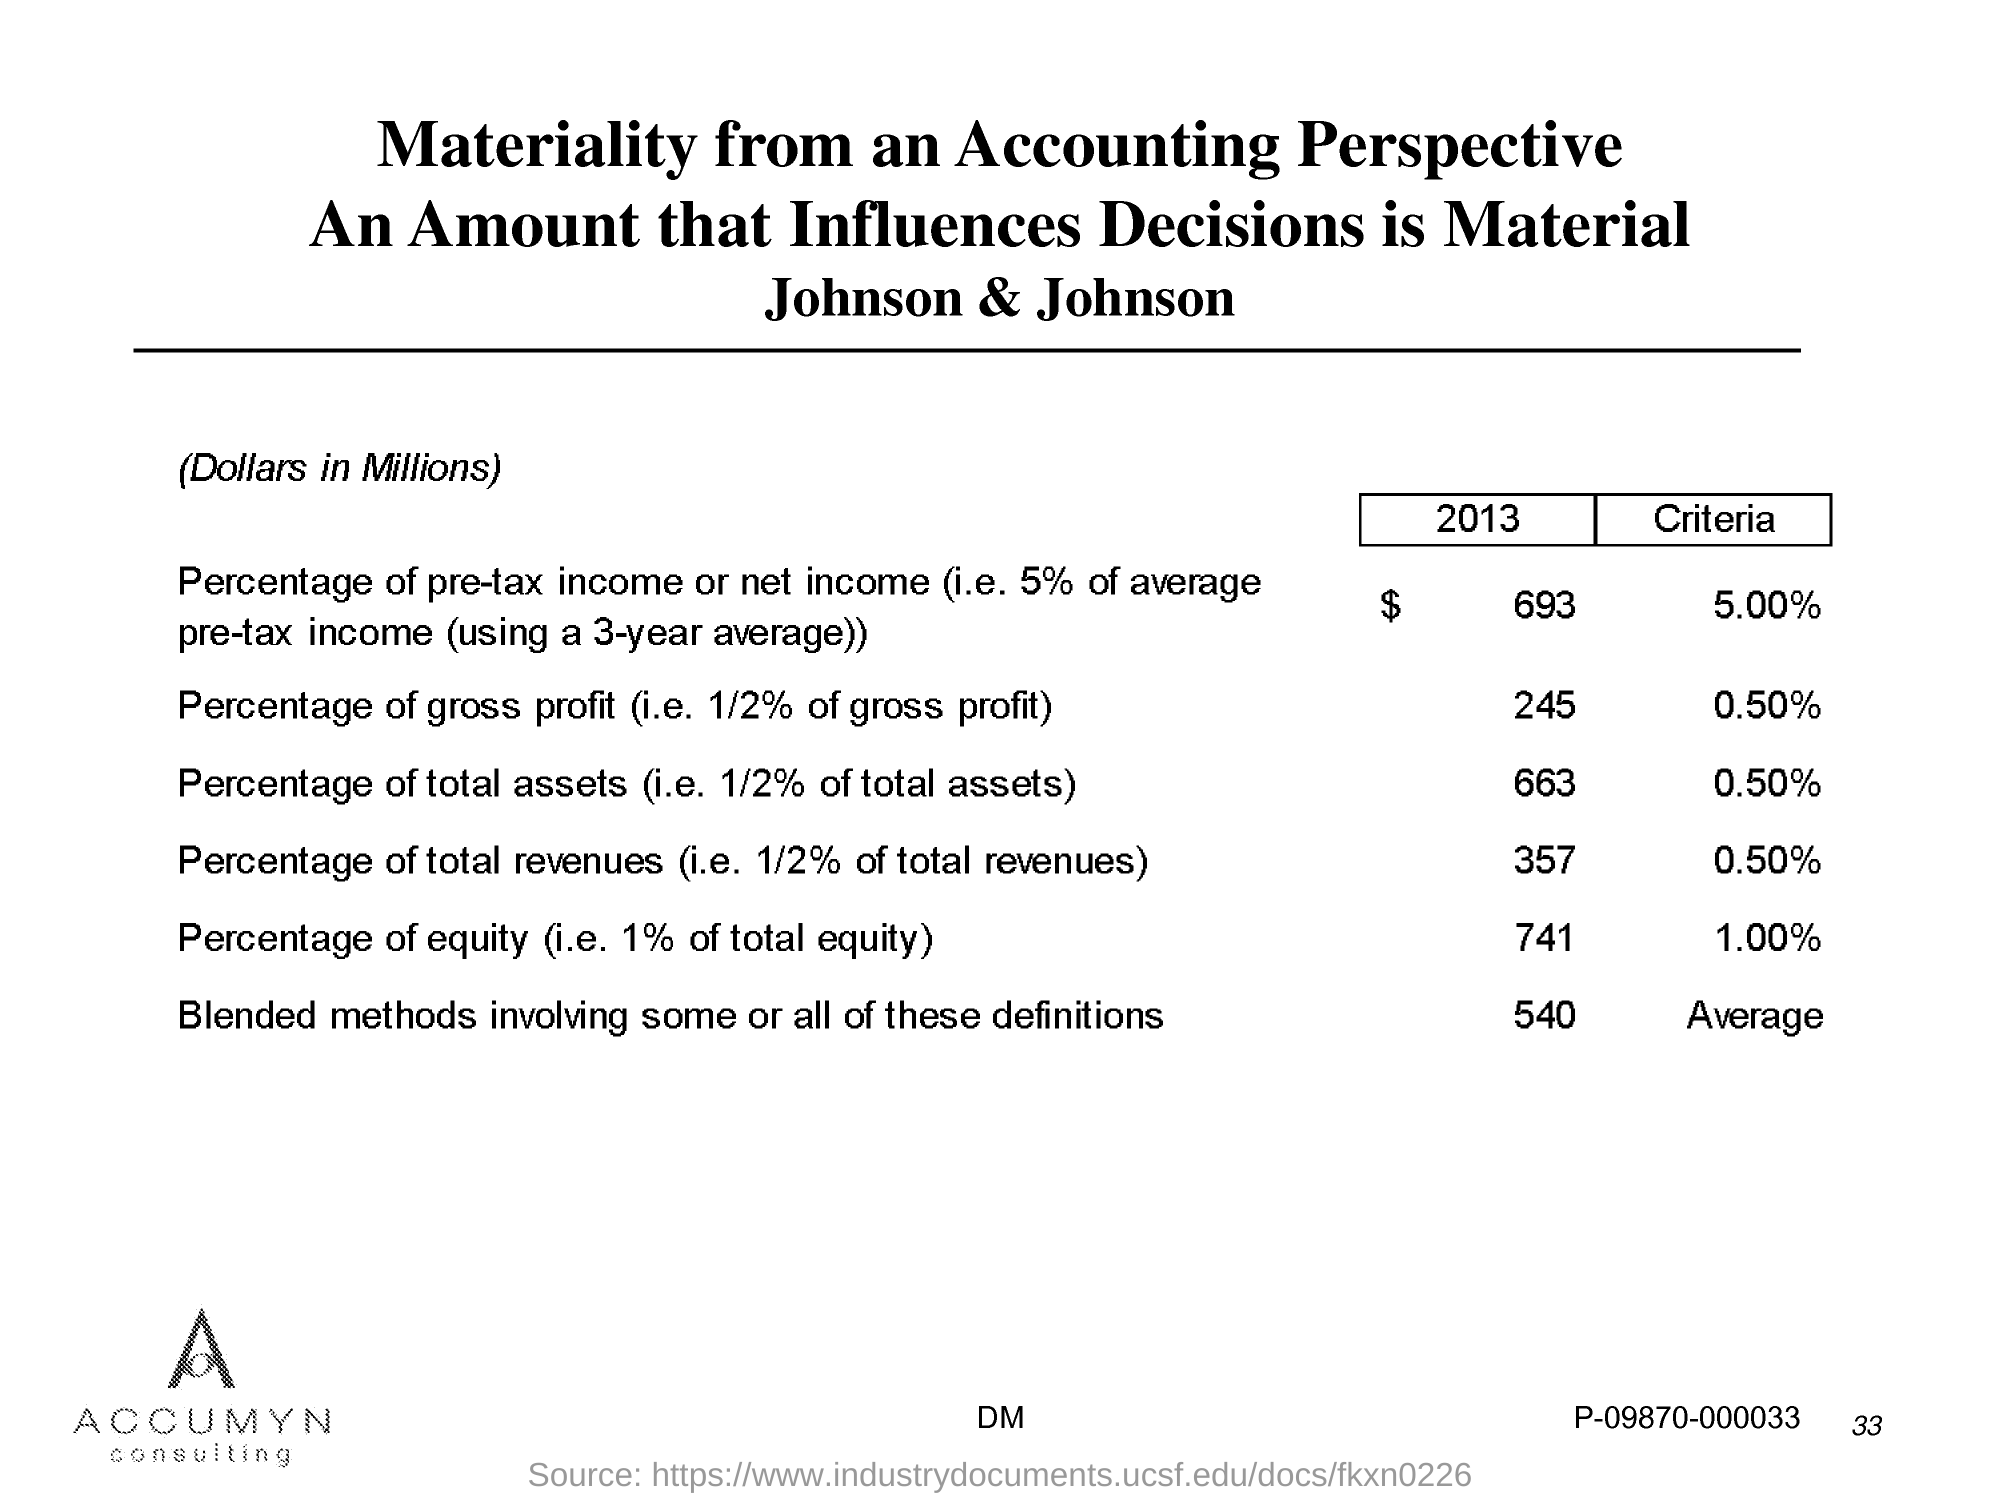What are the other factors listed under the 'Blended methods involving some or all of these definitions'? The 'Blended methods' refer to a combination of various financial metrics such as percentages of pre-tax income, gross profit, total assets, total revenues, and equity. This approach integrates multiple perspectives to provide a more comprehensive assessment of materiality, with the criteria averaging to about 0.90% across different metrics. 